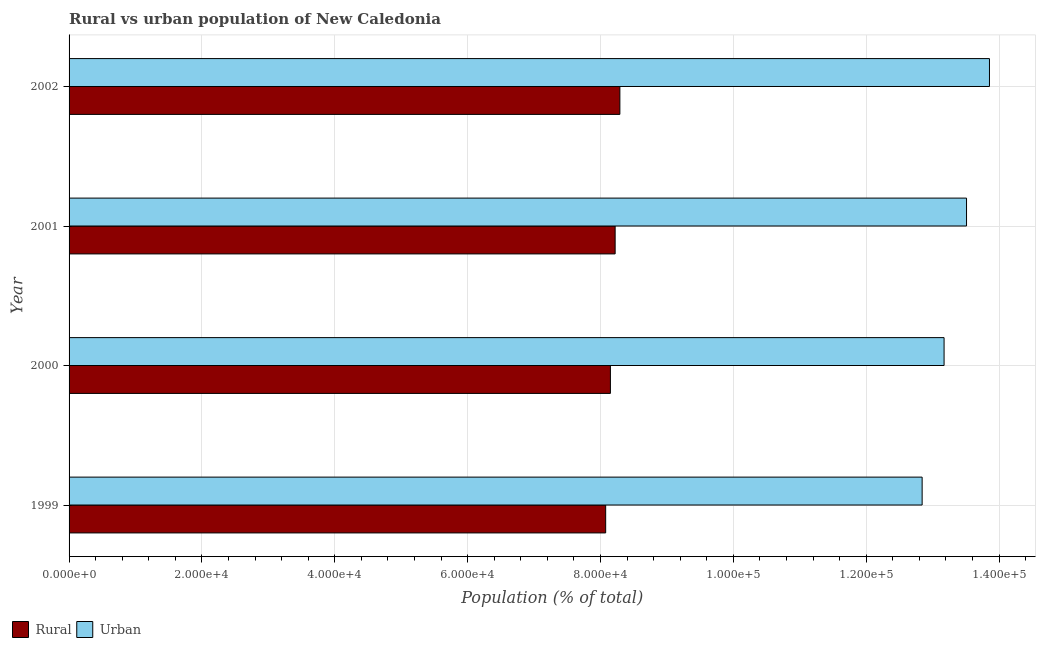How many different coloured bars are there?
Provide a succinct answer. 2. Are the number of bars per tick equal to the number of legend labels?
Provide a succinct answer. Yes. Are the number of bars on each tick of the Y-axis equal?
Give a very brief answer. Yes. What is the urban population density in 2001?
Keep it short and to the point. 1.35e+05. Across all years, what is the maximum rural population density?
Your answer should be compact. 8.29e+04. Across all years, what is the minimum urban population density?
Your answer should be very brief. 1.28e+05. In which year was the urban population density maximum?
Ensure brevity in your answer.  2002. What is the total urban population density in the graph?
Provide a short and direct response. 5.34e+05. What is the difference between the rural population density in 1999 and that in 2000?
Give a very brief answer. -713. What is the difference between the rural population density in 2002 and the urban population density in 2000?
Give a very brief answer. -4.88e+04. What is the average rural population density per year?
Make the answer very short. 8.19e+04. In the year 2001, what is the difference between the rural population density and urban population density?
Offer a terse response. -5.29e+04. Is the rural population density in 2000 less than that in 2001?
Provide a short and direct response. Yes. What is the difference between the highest and the second highest urban population density?
Your answer should be very brief. 3453. What is the difference between the highest and the lowest urban population density?
Provide a succinct answer. 1.01e+04. What does the 1st bar from the top in 2002 represents?
Provide a short and direct response. Urban. What does the 2nd bar from the bottom in 2000 represents?
Provide a short and direct response. Urban. Are all the bars in the graph horizontal?
Provide a succinct answer. Yes. Are the values on the major ticks of X-axis written in scientific E-notation?
Give a very brief answer. Yes. What is the title of the graph?
Ensure brevity in your answer.  Rural vs urban population of New Caledonia. Does "Time to export" appear as one of the legend labels in the graph?
Offer a very short reply. No. What is the label or title of the X-axis?
Ensure brevity in your answer.  Population (% of total). What is the label or title of the Y-axis?
Your answer should be very brief. Year. What is the Population (% of total) in Rural in 1999?
Make the answer very short. 8.08e+04. What is the Population (% of total) in Urban in 1999?
Offer a very short reply. 1.28e+05. What is the Population (% of total) in Rural in 2000?
Keep it short and to the point. 8.15e+04. What is the Population (% of total) in Urban in 2000?
Keep it short and to the point. 1.32e+05. What is the Population (% of total) in Rural in 2001?
Your answer should be compact. 8.22e+04. What is the Population (% of total) of Urban in 2001?
Your response must be concise. 1.35e+05. What is the Population (% of total) in Rural in 2002?
Offer a very short reply. 8.29e+04. What is the Population (% of total) of Urban in 2002?
Offer a very short reply. 1.39e+05. Across all years, what is the maximum Population (% of total) in Rural?
Give a very brief answer. 8.29e+04. Across all years, what is the maximum Population (% of total) in Urban?
Keep it short and to the point. 1.39e+05. Across all years, what is the minimum Population (% of total) in Rural?
Your response must be concise. 8.08e+04. Across all years, what is the minimum Population (% of total) of Urban?
Offer a very short reply. 1.28e+05. What is the total Population (% of total) in Rural in the graph?
Give a very brief answer. 3.27e+05. What is the total Population (% of total) in Urban in the graph?
Keep it short and to the point. 5.34e+05. What is the difference between the Population (% of total) in Rural in 1999 and that in 2000?
Ensure brevity in your answer.  -713. What is the difference between the Population (% of total) of Urban in 1999 and that in 2000?
Provide a short and direct response. -3303. What is the difference between the Population (% of total) in Rural in 1999 and that in 2001?
Provide a succinct answer. -1427. What is the difference between the Population (% of total) in Urban in 1999 and that in 2001?
Provide a short and direct response. -6683. What is the difference between the Population (% of total) of Rural in 1999 and that in 2002?
Your answer should be compact. -2140. What is the difference between the Population (% of total) of Urban in 1999 and that in 2002?
Keep it short and to the point. -1.01e+04. What is the difference between the Population (% of total) of Rural in 2000 and that in 2001?
Offer a terse response. -714. What is the difference between the Population (% of total) of Urban in 2000 and that in 2001?
Make the answer very short. -3380. What is the difference between the Population (% of total) of Rural in 2000 and that in 2002?
Keep it short and to the point. -1427. What is the difference between the Population (% of total) of Urban in 2000 and that in 2002?
Provide a succinct answer. -6833. What is the difference between the Population (% of total) of Rural in 2001 and that in 2002?
Your answer should be very brief. -713. What is the difference between the Population (% of total) of Urban in 2001 and that in 2002?
Offer a terse response. -3453. What is the difference between the Population (% of total) in Rural in 1999 and the Population (% of total) in Urban in 2000?
Offer a terse response. -5.09e+04. What is the difference between the Population (% of total) in Rural in 1999 and the Population (% of total) in Urban in 2001?
Your response must be concise. -5.43e+04. What is the difference between the Population (% of total) in Rural in 1999 and the Population (% of total) in Urban in 2002?
Offer a terse response. -5.78e+04. What is the difference between the Population (% of total) of Rural in 2000 and the Population (% of total) of Urban in 2001?
Give a very brief answer. -5.36e+04. What is the difference between the Population (% of total) of Rural in 2000 and the Population (% of total) of Urban in 2002?
Make the answer very short. -5.71e+04. What is the difference between the Population (% of total) of Rural in 2001 and the Population (% of total) of Urban in 2002?
Your answer should be very brief. -5.64e+04. What is the average Population (% of total) of Rural per year?
Your answer should be compact. 8.19e+04. What is the average Population (% of total) of Urban per year?
Provide a short and direct response. 1.33e+05. In the year 1999, what is the difference between the Population (% of total) in Rural and Population (% of total) in Urban?
Make the answer very short. -4.76e+04. In the year 2000, what is the difference between the Population (% of total) of Rural and Population (% of total) of Urban?
Offer a very short reply. -5.02e+04. In the year 2001, what is the difference between the Population (% of total) in Rural and Population (% of total) in Urban?
Offer a very short reply. -5.29e+04. In the year 2002, what is the difference between the Population (% of total) of Rural and Population (% of total) of Urban?
Offer a terse response. -5.56e+04. What is the ratio of the Population (% of total) of Rural in 1999 to that in 2000?
Provide a succinct answer. 0.99. What is the ratio of the Population (% of total) in Urban in 1999 to that in 2000?
Provide a succinct answer. 0.97. What is the ratio of the Population (% of total) in Rural in 1999 to that in 2001?
Your response must be concise. 0.98. What is the ratio of the Population (% of total) in Urban in 1999 to that in 2001?
Ensure brevity in your answer.  0.95. What is the ratio of the Population (% of total) of Rural in 1999 to that in 2002?
Your answer should be very brief. 0.97. What is the ratio of the Population (% of total) of Urban in 1999 to that in 2002?
Give a very brief answer. 0.93. What is the ratio of the Population (% of total) of Rural in 2000 to that in 2001?
Your answer should be very brief. 0.99. What is the ratio of the Population (% of total) of Rural in 2000 to that in 2002?
Give a very brief answer. 0.98. What is the ratio of the Population (% of total) of Urban in 2000 to that in 2002?
Give a very brief answer. 0.95. What is the ratio of the Population (% of total) in Rural in 2001 to that in 2002?
Your answer should be very brief. 0.99. What is the ratio of the Population (% of total) of Urban in 2001 to that in 2002?
Ensure brevity in your answer.  0.98. What is the difference between the highest and the second highest Population (% of total) of Rural?
Provide a short and direct response. 713. What is the difference between the highest and the second highest Population (% of total) in Urban?
Provide a succinct answer. 3453. What is the difference between the highest and the lowest Population (% of total) of Rural?
Make the answer very short. 2140. What is the difference between the highest and the lowest Population (% of total) in Urban?
Your answer should be compact. 1.01e+04. 